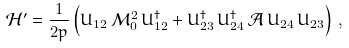<formula> <loc_0><loc_0><loc_500><loc_500>\mathcal { H } ^ { \prime } = \frac { 1 } { 2 p } \left ( U _ { 1 2 } \, \mathcal { M } _ { 0 } ^ { 2 } \, U _ { 1 2 } ^ { \dagger } + U _ { 2 3 } ^ { \dagger } \, U _ { 2 4 } ^ { \dagger } \, \mathcal { A } \, U _ { 2 4 } \, U _ { 2 3 } \right ) \, ,</formula> 